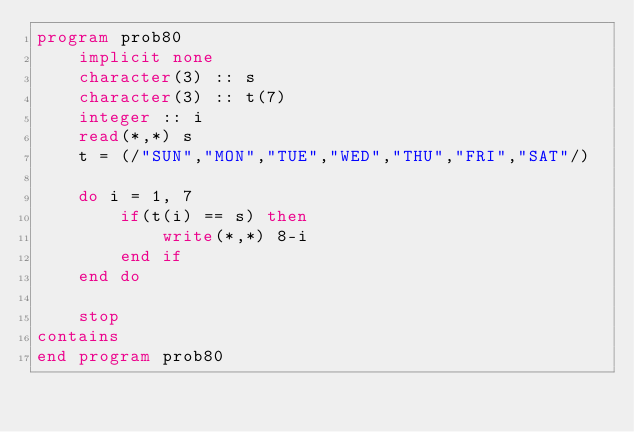Convert code to text. <code><loc_0><loc_0><loc_500><loc_500><_FORTRAN_>program prob80
    implicit none
    character(3) :: s
    character(3) :: t(7)
    integer :: i
    read(*,*) s
    t = (/"SUN","MON","TUE","WED","THU","FRI","SAT"/)

    do i = 1, 7
        if(t(i) == s) then
            write(*,*) 8-i
        end if
    end do

    stop
contains
end program prob80</code> 